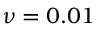Convert formula to latex. <formula><loc_0><loc_0><loc_500><loc_500>\nu = 0 . 0 1</formula> 